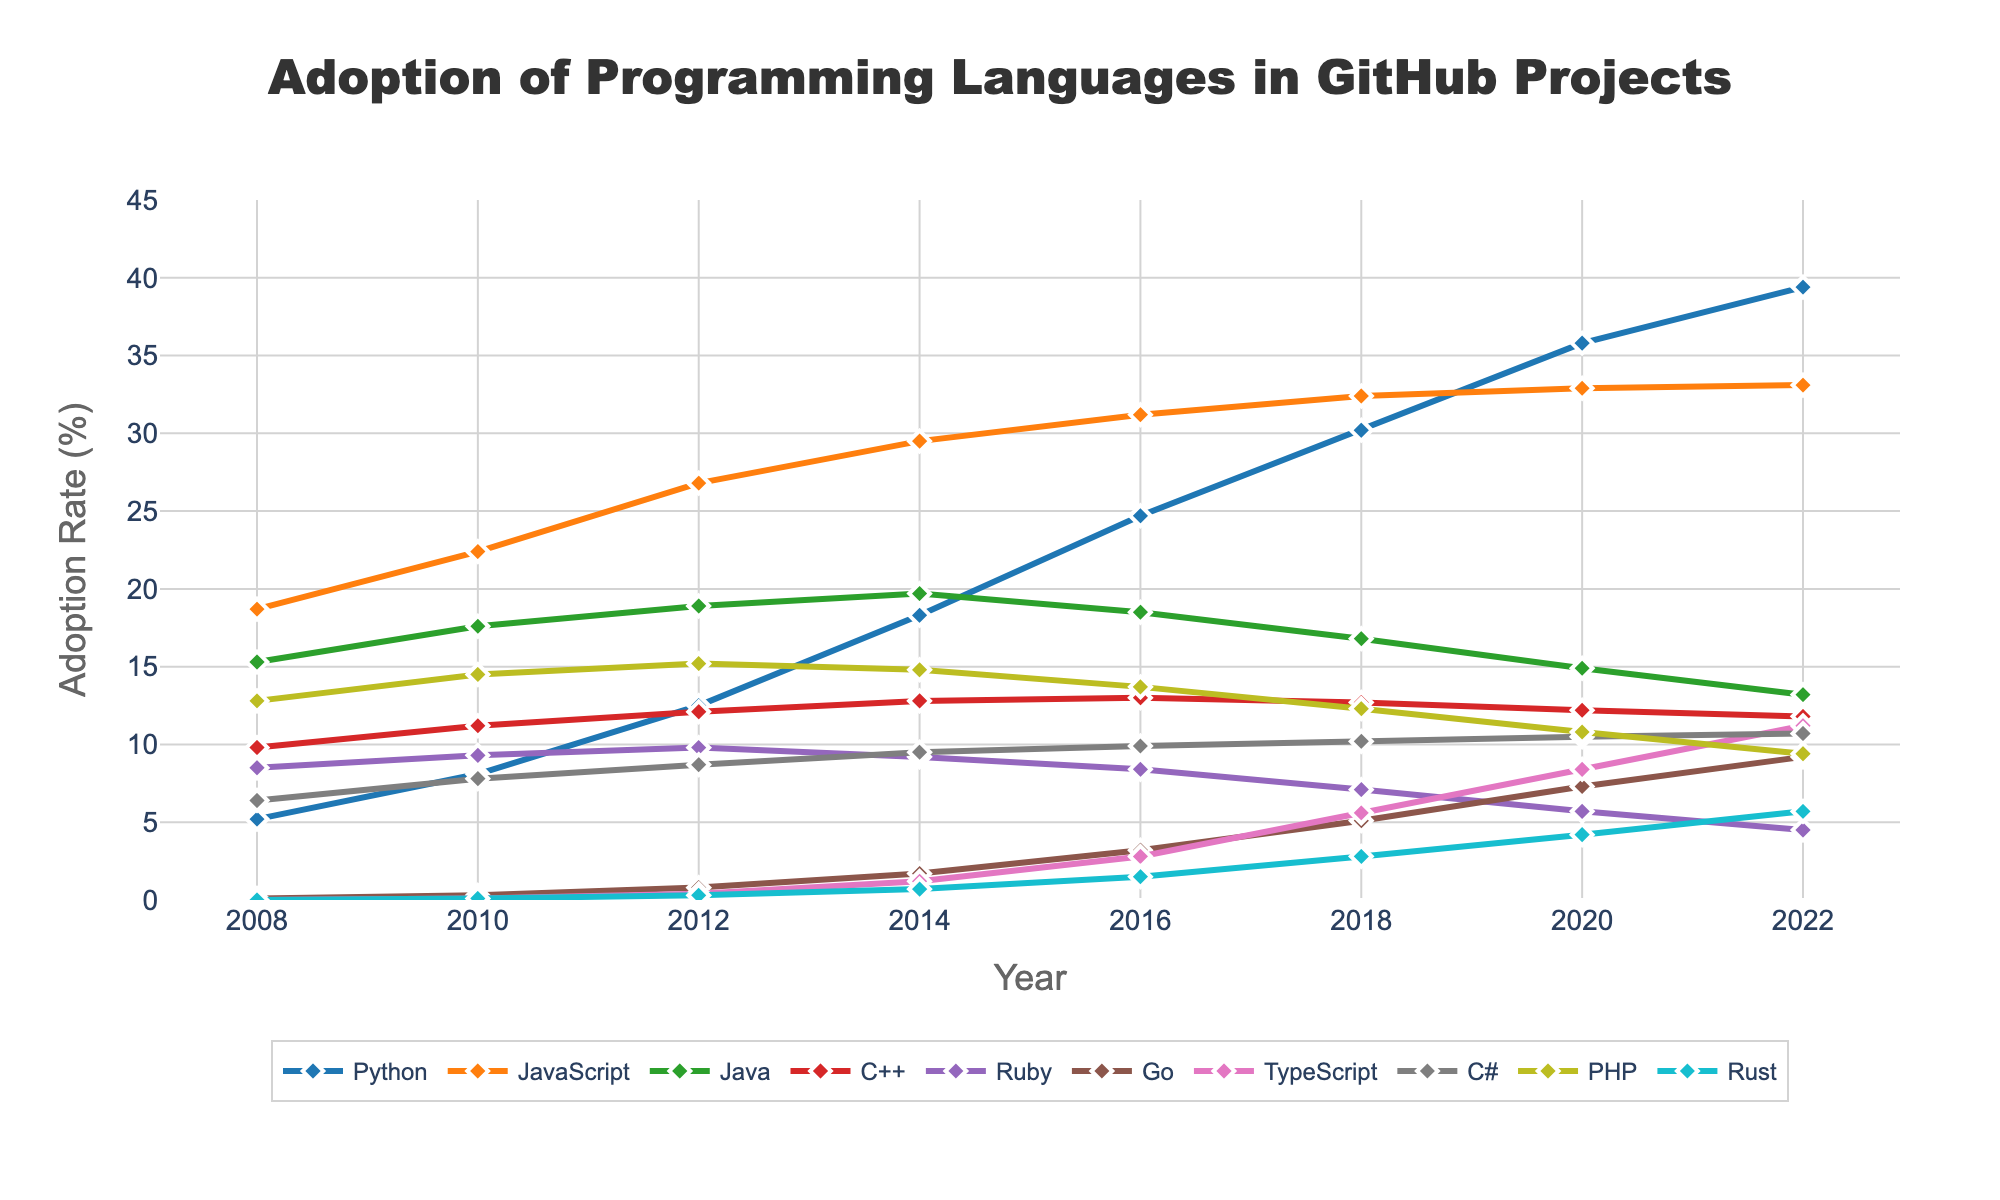What is the adoption rate of Python in 2014? Look for the data point for Python in the year 2014. From the graph, Python has an adoption rate of 18.3% in 2014.
Answer: 18.3% Which programming language had the highest adoption rate in 2008? In the year 2008, refer to the adoption rates of all the programming languages. JavaScript had the highest adoption rate at 18.7%.
Answer: JavaScript What is the overall trend for the adoption rate of TypeScript from 2012 to 2022? Track the data points for TypeScript from 2012 to 2022. Its adoption rate increases from 0.4% in 2012 to 11.2% in 2022, showing an overall upward trend.
Answer: Upward Which language had a higher adoption rate in 2020: Go or PHP? Refer to the adoption rates for Go and PHP in 2020. Go had an adoption rate of 7.3%, and PHP had an adoption rate of 10.8%. Thus, PHP had a higher adoption rate.
Answer: PHP How much did the adoption rate of Rust increase between 2010 and 2022? Calculate the difference in adoption rates of Rust between 2010 and 2022. In 2010, Rust had a 0.1% adoption rate, and in 2022, it was 5.7%. The increase is 5.7% - 0.1% = 5.6%.
Answer: 5.6% Which language had the least change in its adoption rate from 2008 to 2022? Compare the adoption rates of all languages between 2008 and 2022 to see which had the smallest change. Ruby changed from 8.5% to 4.5%, a decrease of 4%, which is the smallest change among all languages.
Answer: Ruby By how much did Python's adoption rate exceed Java's in 2022? Subtract Java's adoption rate from Python's adoption rate in 2022. Python had 39.4% and Java had 13.2%. The difference is 39.4% - 13.2% = 26.2%.
Answer: 26.2% Which year did Python's adoption rate first exceed 20%? Look at the adoption rates of Python over the years. Python first exceeds 20% in 2016 with an adoption rate of 24.7%.
Answer: 2016 What was the average adoption rate of C++ from 2008 to 2022? Sum the adoption rates of C++ from 2008 to 2022 and divide by the number of data points. The sum is (9.8 + 11.2 + 12.1 + 12.8 + 13.0 + 12.7 + 12.2 + 11.8) = 95.6. There are 8 years, so the average is 95.6 / 8 = 11.95%.
Answer: 11.95% 